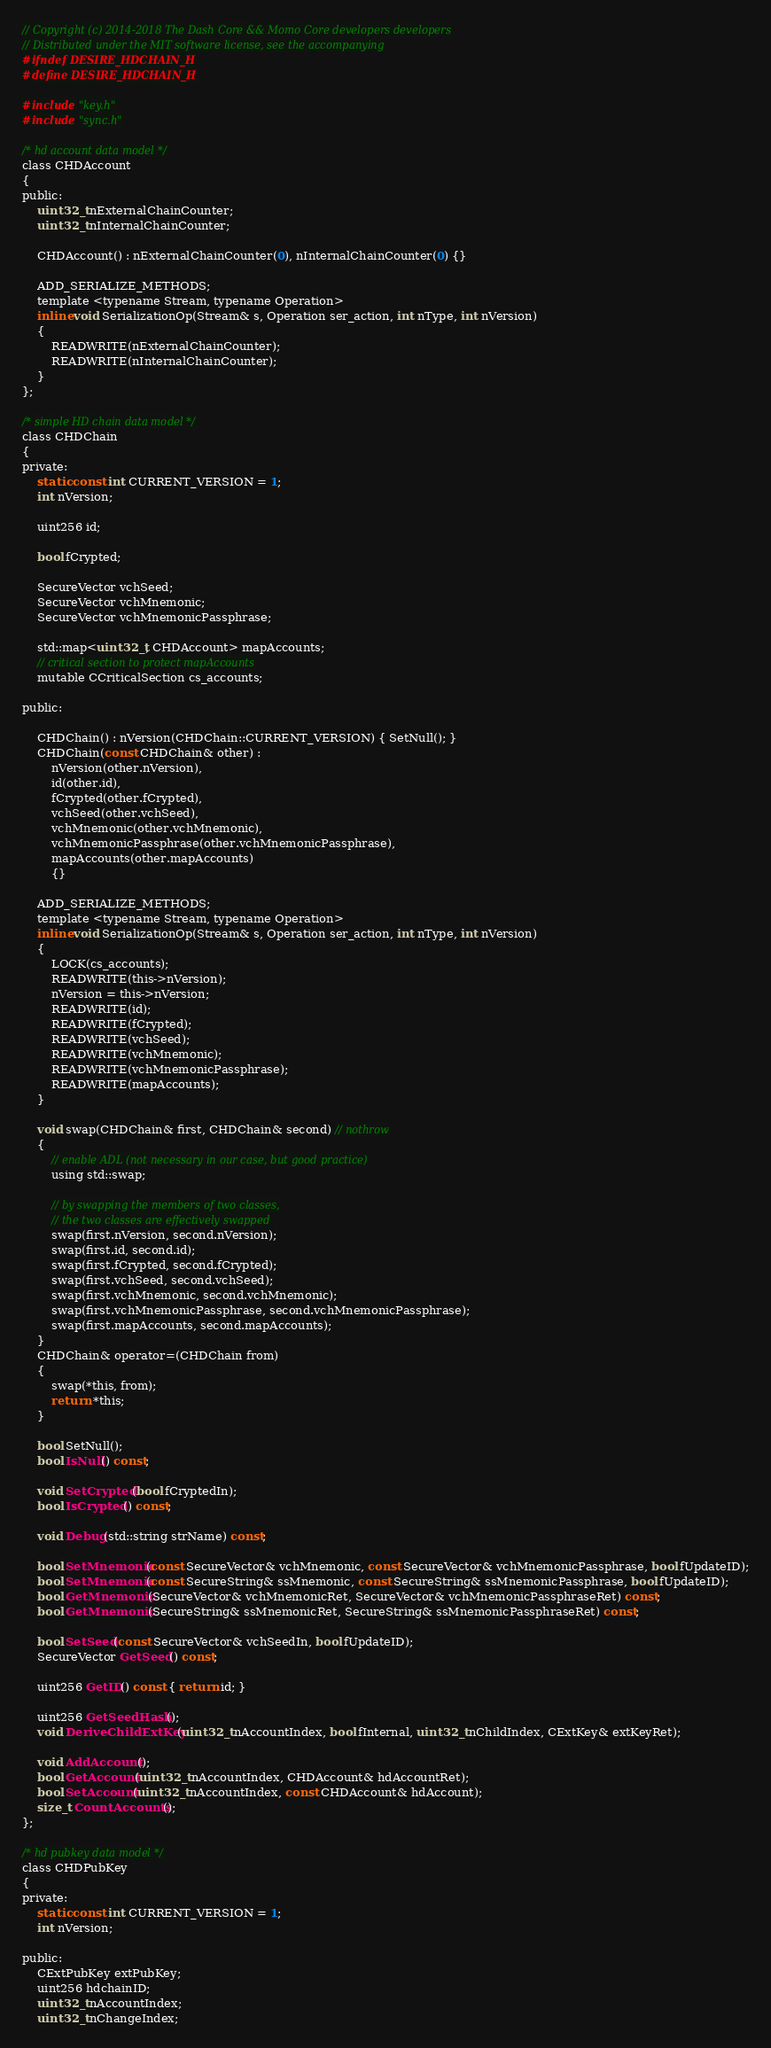Convert code to text. <code><loc_0><loc_0><loc_500><loc_500><_C_>// Copyright (c) 2014-2018 The Dash Core && Momo Core developers developers
// Distributed under the MIT software license, see the accompanying
#ifndef DESIRE_HDCHAIN_H
#define DESIRE_HDCHAIN_H

#include "key.h"
#include "sync.h"

/* hd account data model */
class CHDAccount
{
public:
    uint32_t nExternalChainCounter;
    uint32_t nInternalChainCounter;

    CHDAccount() : nExternalChainCounter(0), nInternalChainCounter(0) {}

    ADD_SERIALIZE_METHODS;
    template <typename Stream, typename Operation>
    inline void SerializationOp(Stream& s, Operation ser_action, int nType, int nVersion)
    {
        READWRITE(nExternalChainCounter);
        READWRITE(nInternalChainCounter);
    }
};

/* simple HD chain data model */
class CHDChain
{
private:
    static const int CURRENT_VERSION = 1;
    int nVersion;

    uint256 id;

    bool fCrypted;

    SecureVector vchSeed;
    SecureVector vchMnemonic;
    SecureVector vchMnemonicPassphrase;

    std::map<uint32_t, CHDAccount> mapAccounts;
    // critical section to protect mapAccounts
    mutable CCriticalSection cs_accounts;

public:

    CHDChain() : nVersion(CHDChain::CURRENT_VERSION) { SetNull(); }
    CHDChain(const CHDChain& other) :
        nVersion(other.nVersion),
        id(other.id),
        fCrypted(other.fCrypted),
        vchSeed(other.vchSeed),
        vchMnemonic(other.vchMnemonic),
        vchMnemonicPassphrase(other.vchMnemonicPassphrase),
        mapAccounts(other.mapAccounts)
        {}

    ADD_SERIALIZE_METHODS;
    template <typename Stream, typename Operation>
    inline void SerializationOp(Stream& s, Operation ser_action, int nType, int nVersion)
    {
        LOCK(cs_accounts);
        READWRITE(this->nVersion);
        nVersion = this->nVersion;
        READWRITE(id);
        READWRITE(fCrypted);
        READWRITE(vchSeed);
        READWRITE(vchMnemonic);
        READWRITE(vchMnemonicPassphrase);
        READWRITE(mapAccounts);
    }

    void swap(CHDChain& first, CHDChain& second) // nothrow
    {
        // enable ADL (not necessary in our case, but good practice)
        using std::swap;

        // by swapping the members of two classes,
        // the two classes are effectively swapped
        swap(first.nVersion, second.nVersion);
        swap(first.id, second.id);
        swap(first.fCrypted, second.fCrypted);
        swap(first.vchSeed, second.vchSeed);
        swap(first.vchMnemonic, second.vchMnemonic);
        swap(first.vchMnemonicPassphrase, second.vchMnemonicPassphrase);
        swap(first.mapAccounts, second.mapAccounts);
    }
    CHDChain& operator=(CHDChain from)
    {
        swap(*this, from);
        return *this;
    }

    bool SetNull();
    bool IsNull() const;

    void SetCrypted(bool fCryptedIn);
    bool IsCrypted() const;

    void Debug(std::string strName) const;

    bool SetMnemonic(const SecureVector& vchMnemonic, const SecureVector& vchMnemonicPassphrase, bool fUpdateID);
    bool SetMnemonic(const SecureString& ssMnemonic, const SecureString& ssMnemonicPassphrase, bool fUpdateID);
    bool GetMnemonic(SecureVector& vchMnemonicRet, SecureVector& vchMnemonicPassphraseRet) const;
    bool GetMnemonic(SecureString& ssMnemonicRet, SecureString& ssMnemonicPassphraseRet) const;

    bool SetSeed(const SecureVector& vchSeedIn, bool fUpdateID);
    SecureVector GetSeed() const;

    uint256 GetID() const { return id; }

    uint256 GetSeedHash();
    void DeriveChildExtKey(uint32_t nAccountIndex, bool fInternal, uint32_t nChildIndex, CExtKey& extKeyRet);

    void AddAccount();
    bool GetAccount(uint32_t nAccountIndex, CHDAccount& hdAccountRet);
    bool SetAccount(uint32_t nAccountIndex, const CHDAccount& hdAccount);
    size_t CountAccounts();
};

/* hd pubkey data model */
class CHDPubKey
{
private:
    static const int CURRENT_VERSION = 1;
    int nVersion;

public:
    CExtPubKey extPubKey;
    uint256 hdchainID;
    uint32_t nAccountIndex;
    uint32_t nChangeIndex;
</code> 